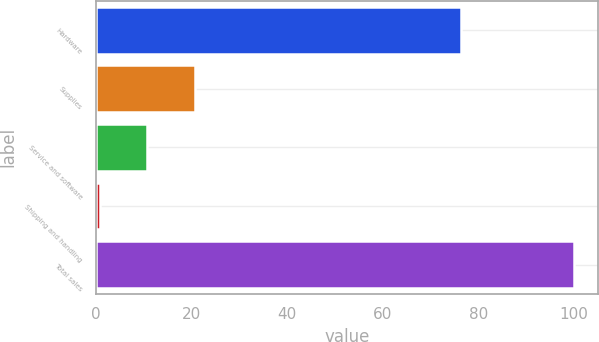Convert chart. <chart><loc_0><loc_0><loc_500><loc_500><bar_chart><fcel>Hardware<fcel>Supplies<fcel>Service and software<fcel>Shipping and handling<fcel>Total sales<nl><fcel>76.3<fcel>20.64<fcel>10.72<fcel>0.8<fcel>100<nl></chart> 